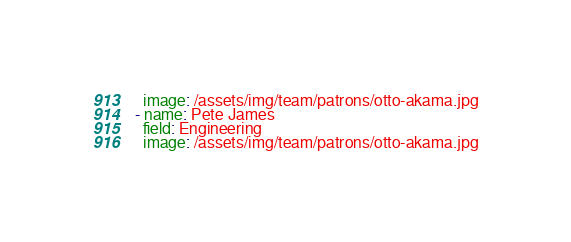<code> <loc_0><loc_0><loc_500><loc_500><_YAML_>  image: /assets/img/team/patrons/otto-akama.jpg
- name: Pete James
  field: Engineering
  image: /assets/img/team/patrons/otto-akama.jpg
</code> 